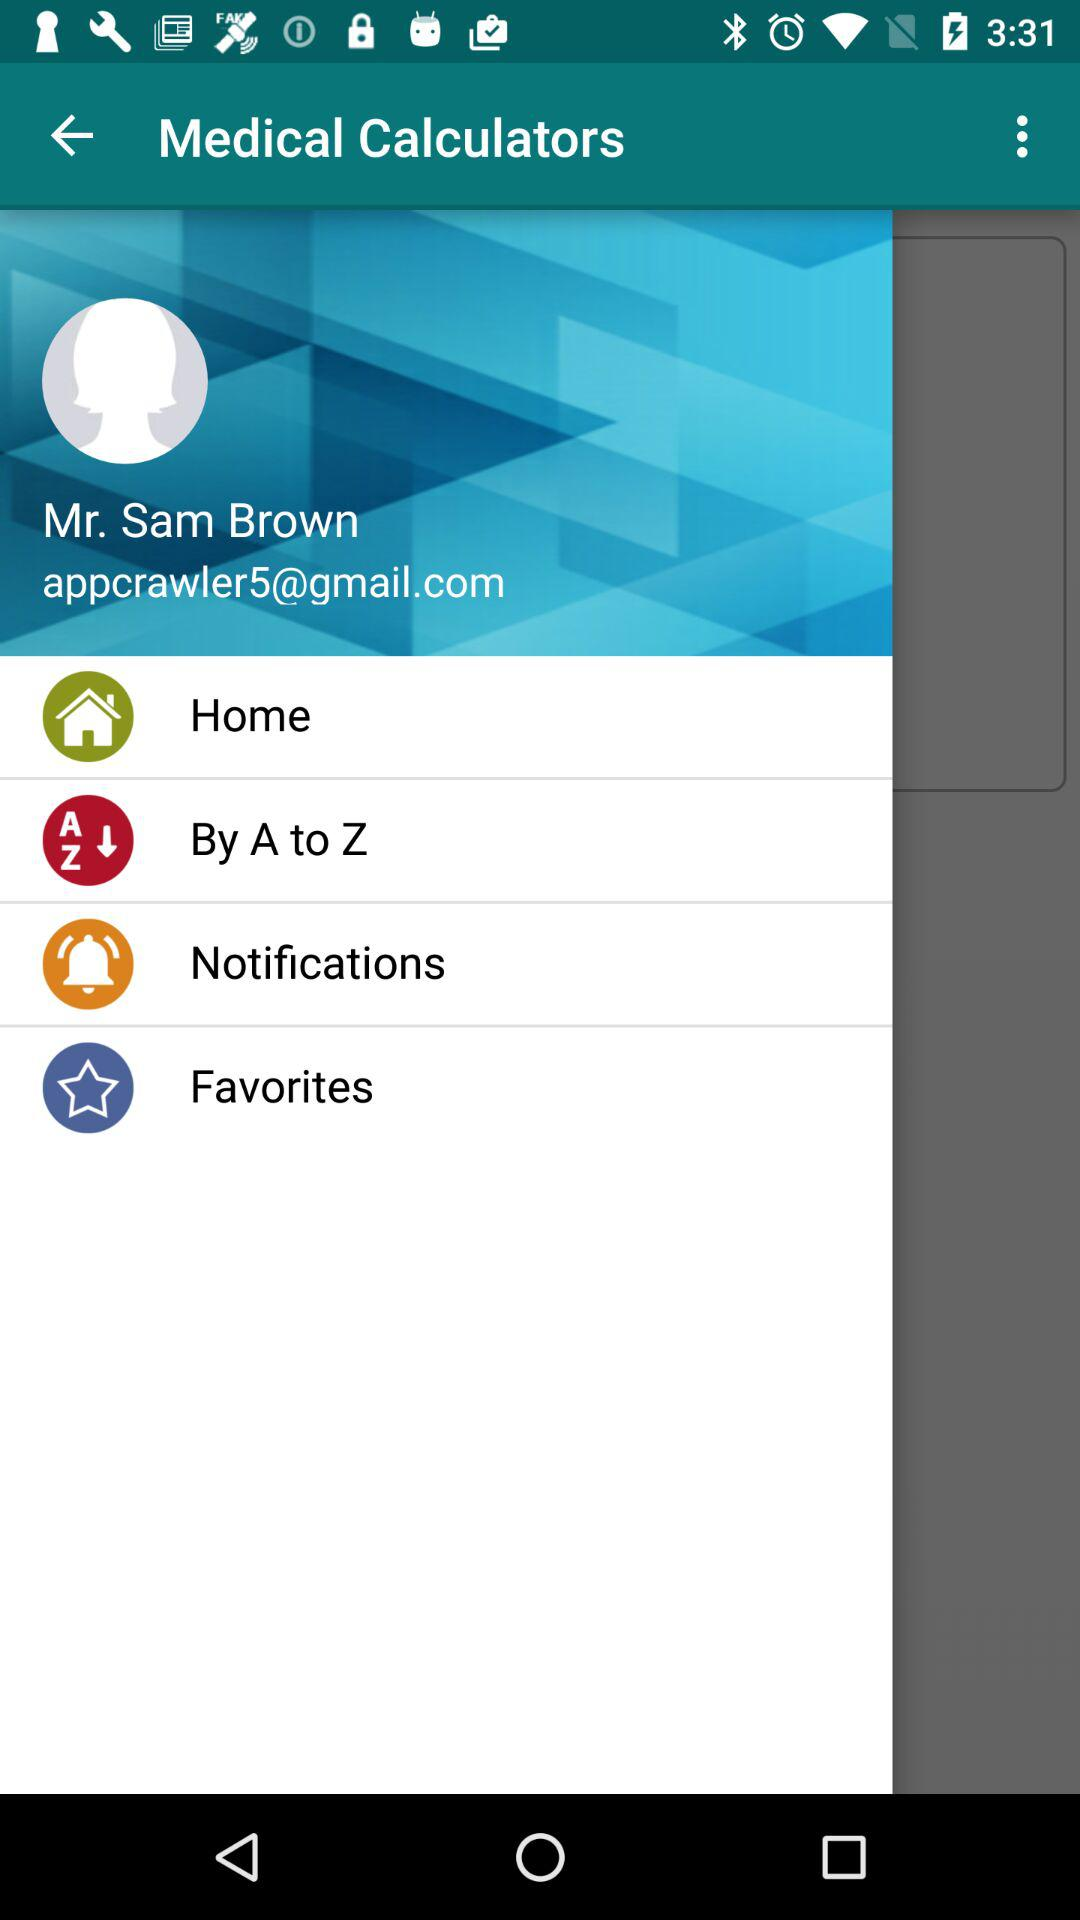What is the profile name? The profile name is Mr. Sam Brown. 